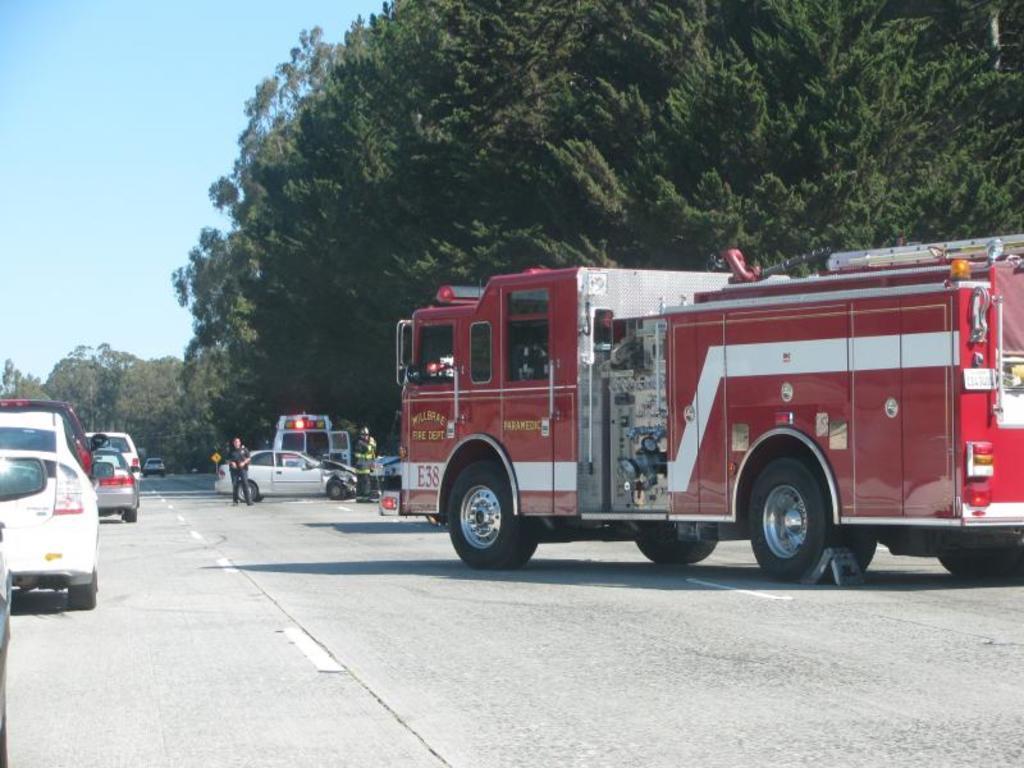Describe this image in one or two sentences. In this image there is a road on which there is a fire engine on the right side. Beside the fire engine there are cars one after the other on the road. In the background there is an ambulance. Inside the ambulance there is a car and few police officers. In the background there are trees. At the top there is the sky. 